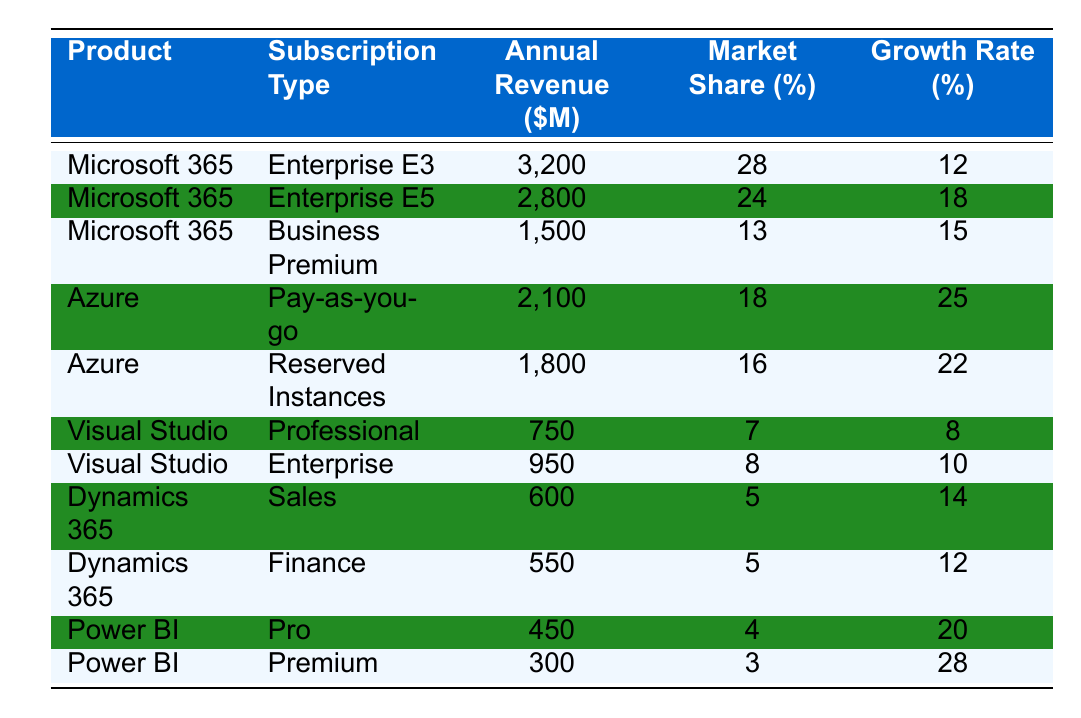What's the annual revenue from Microsoft 365's Enterprise E5 subscription? The table directly states that the annual revenue from the Microsoft 365 Enterprise E5 subscription is 2,800 million dollars.
Answer: 2,800 million dollars Which product has the highest market share? Looking through the table, Microsoft 365's Enterprise E3 subscription has the highest market share at 28%.
Answer: Microsoft 365 Enterprise E3 What is the total annual revenue from all Power BI subscriptions? The total annual revenue from Power BI can be calculated by adding the revenues of the Pro ($450 million) and Premium ($300 million) subscriptions: 450 + 300 = 750 million dollars.
Answer: 750 million dollars Is the growth rate of Azure's Reserved Instances higher than that of Visual Studio's Professional subscription? The growth rate of Azure's Reserved Instances is 22%, while Visual Studio's Professional is 8%. Since 22% is greater than 8%, the answer is yes.
Answer: Yes What is the average growth rate of all Microsoft 365 subscriptions? The growth rates are 12%, 18%, and 15% for the three subscriptions. The average is calculated as (12 + 18 + 15) / 3 = 15%.
Answer: 15% Which subscription type contributes more revenue, Azure's Pay-as-you-go or Microsoft 365's Business Premium? Azure's Pay-as-you-go generates 2,100 million dollars, while Microsoft 365's Business Premium generates 1,500 million dollars. Since 2,100 > 1,500, Azure's Pay-as-you-go contributes more revenue.
Answer: Azure's Pay-as-you-go What percentage of the market share do all Dynamics 365 subscriptions together hold? The market shares for Dynamics 365 subscriptions are 5% for Sales and 5% for Finance. Together, they hold 5 + 5 = 10% of the market share.
Answer: 10% Which product has the lowest annual revenue? Upon examining the table, Power BI's Premium subscription has the lowest annual revenue at 300 million dollars.
Answer: Power BI Premium Does Microsoft 365's Enterprise E3 subscription show a higher growth rate than Power BI's Premium subscription? The growth rate for Microsoft 365's Enterprise E3 is 12% while Power BI's Premium shows 28%. Since 12% is less than 28%, the answer is no.
Answer: No What is the combined annual revenue from all Visual Studio subscriptions? The combined annual revenue is calculated by adding the Professional ($750 million) and Enterprise ($950 million) revenues: 750 + 950 = 1,700 million dollars.
Answer: 1,700 million dollars How does the market share of Azure's Reserved Instances compare to that of Dynamics 365's Sales? Azure's Reserved Instances has a market share of 16%, while Dynamics 365's Sales has 5%. Since 16% is greater than 5%, Azure's Reserved Instances has a higher market share.
Answer: Higher market share for Azure's Reserved Instances 